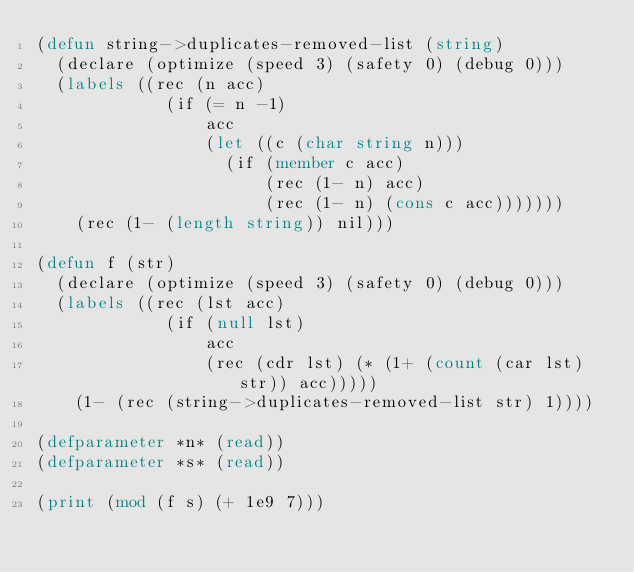<code> <loc_0><loc_0><loc_500><loc_500><_Lisp_>(defun string->duplicates-removed-list (string)
  (declare (optimize (speed 3) (safety 0) (debug 0)))
  (labels ((rec (n acc)
             (if (= n -1)
                 acc
                 (let ((c (char string n)))
                   (if (member c acc)
                       (rec (1- n) acc)
                       (rec (1- n) (cons c acc)))))))
    (rec (1- (length string)) nil)))

(defun f (str)
  (declare (optimize (speed 3) (safety 0) (debug 0)))
  (labels ((rec (lst acc)
             (if (null lst)
                 acc
                 (rec (cdr lst) (* (1+ (count (car lst) str)) acc)))))
    (1- (rec (string->duplicates-removed-list str) 1))))

(defparameter *n* (read))
(defparameter *s* (read))

(print (mod (f s) (+ 1e9 7)))
</code> 